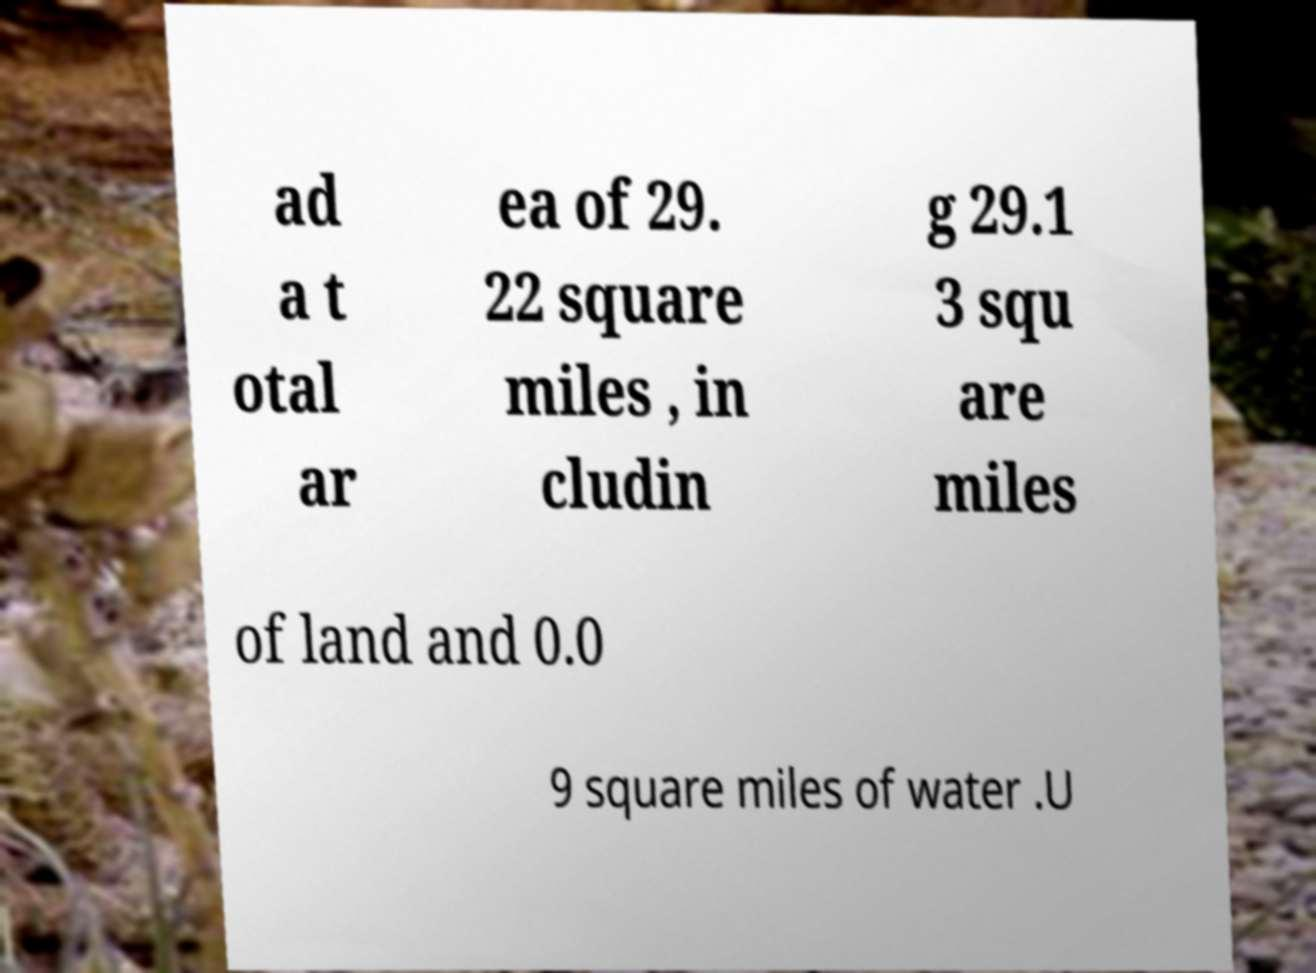Could you extract and type out the text from this image? ad a t otal ar ea of 29. 22 square miles , in cludin g 29.1 3 squ are miles of land and 0.0 9 square miles of water .U 